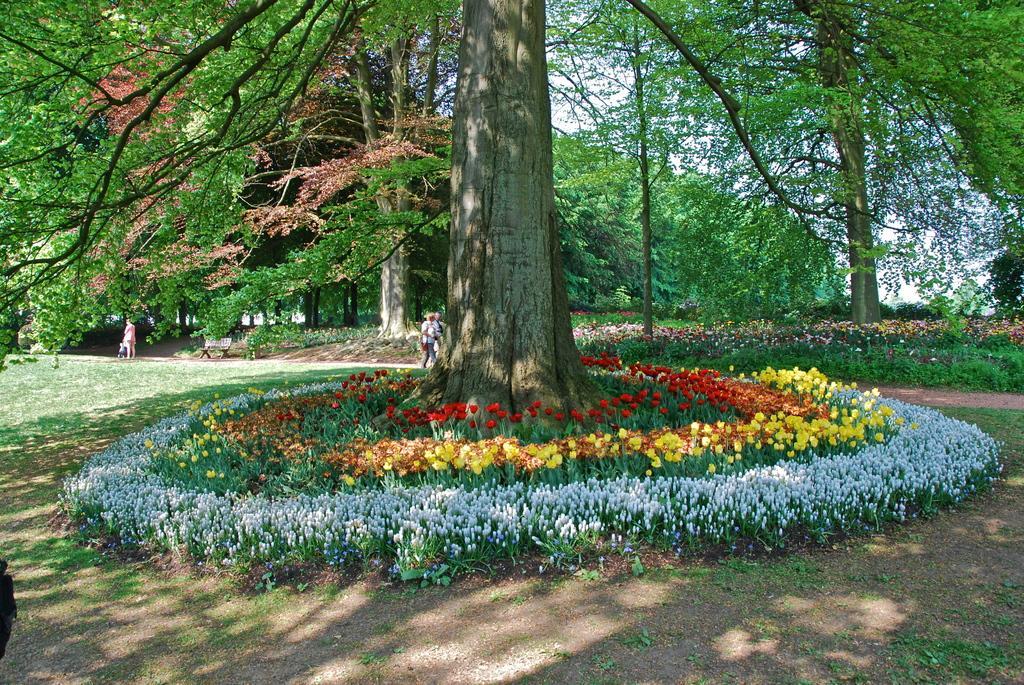Describe this image in one or two sentences. In this image I can see the ground and few plants to which I can see few flowers which are white, yellow, orange and red in color. In the background I can see few persons standing on the ground, a bench, few trees, few flowers which are pink in color and the sky. 